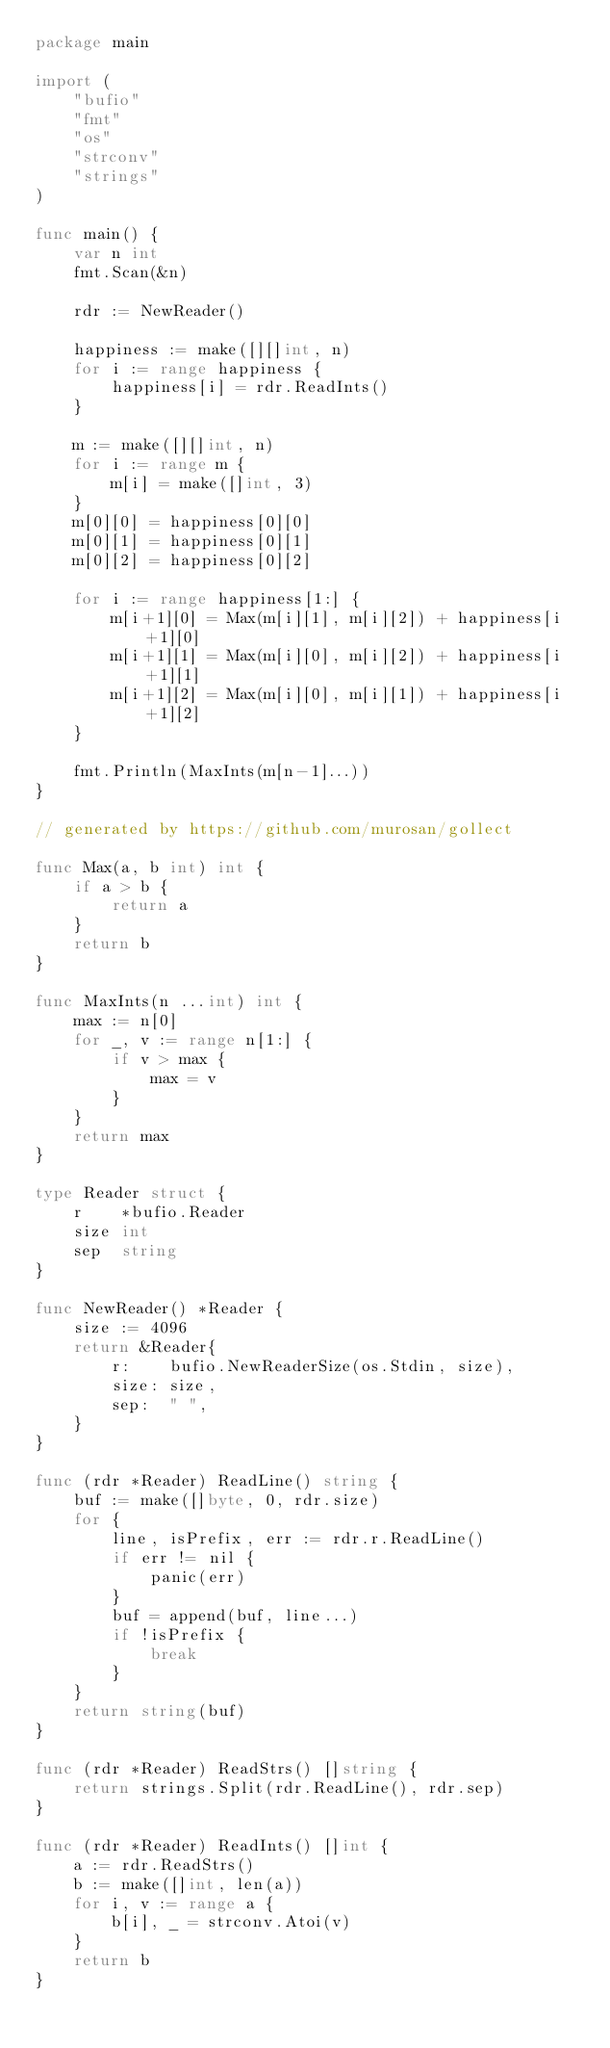Convert code to text. <code><loc_0><loc_0><loc_500><loc_500><_Go_>package main

import (
	"bufio"
	"fmt"
	"os"
	"strconv"
	"strings"
)

func main() {
	var n int
	fmt.Scan(&n)

	rdr := NewReader()

	happiness := make([][]int, n)
	for i := range happiness {
		happiness[i] = rdr.ReadInts()
	}

	m := make([][]int, n)
	for i := range m {
		m[i] = make([]int, 3)
	}
	m[0][0] = happiness[0][0]
	m[0][1] = happiness[0][1]
	m[0][2] = happiness[0][2]

	for i := range happiness[1:] {
		m[i+1][0] = Max(m[i][1], m[i][2]) + happiness[i+1][0]
		m[i+1][1] = Max(m[i][0], m[i][2]) + happiness[i+1][1]
		m[i+1][2] = Max(m[i][0], m[i][1]) + happiness[i+1][2]
	}

	fmt.Println(MaxInts(m[n-1]...))
}

// generated by https://github.com/murosan/gollect

func Max(a, b int) int {
	if a > b {
		return a
	}
	return b
}

func MaxInts(n ...int) int {
	max := n[0]
	for _, v := range n[1:] {
		if v > max {
			max = v
		}
	}
	return max
}

type Reader struct {
	r    *bufio.Reader
	size int
	sep  string
}

func NewReader() *Reader {
	size := 4096
	return &Reader{
		r:    bufio.NewReaderSize(os.Stdin, size),
		size: size,
		sep:  " ",
	}
}

func (rdr *Reader) ReadLine() string {
	buf := make([]byte, 0, rdr.size)
	for {
		line, isPrefix, err := rdr.r.ReadLine()
		if err != nil {
			panic(err)
		}
		buf = append(buf, line...)
		if !isPrefix {
			break
		}
	}
	return string(buf)
}

func (rdr *Reader) ReadStrs() []string {
	return strings.Split(rdr.ReadLine(), rdr.sep)
}

func (rdr *Reader) ReadInts() []int {
	a := rdr.ReadStrs()
	b := make([]int, len(a))
	for i, v := range a {
		b[i], _ = strconv.Atoi(v)
	}
	return b
}
</code> 